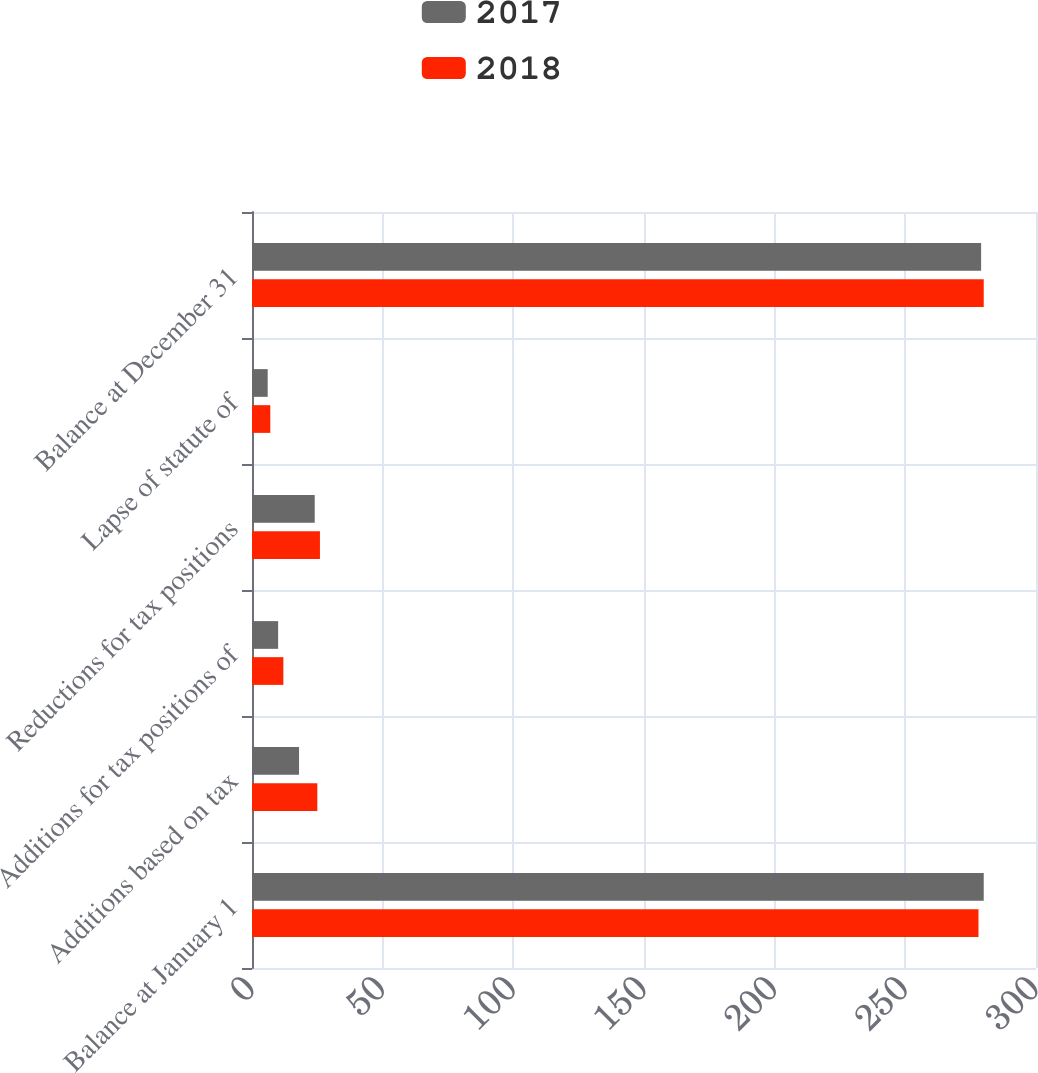Convert chart. <chart><loc_0><loc_0><loc_500><loc_500><stacked_bar_chart><ecel><fcel>Balance at January 1<fcel>Additions based on tax<fcel>Additions for tax positions of<fcel>Reductions for tax positions<fcel>Lapse of statute of<fcel>Balance at December 31<nl><fcel>2017<fcel>280<fcel>18<fcel>10<fcel>24<fcel>6<fcel>279<nl><fcel>2018<fcel>278<fcel>25<fcel>12<fcel>26<fcel>7<fcel>280<nl></chart> 